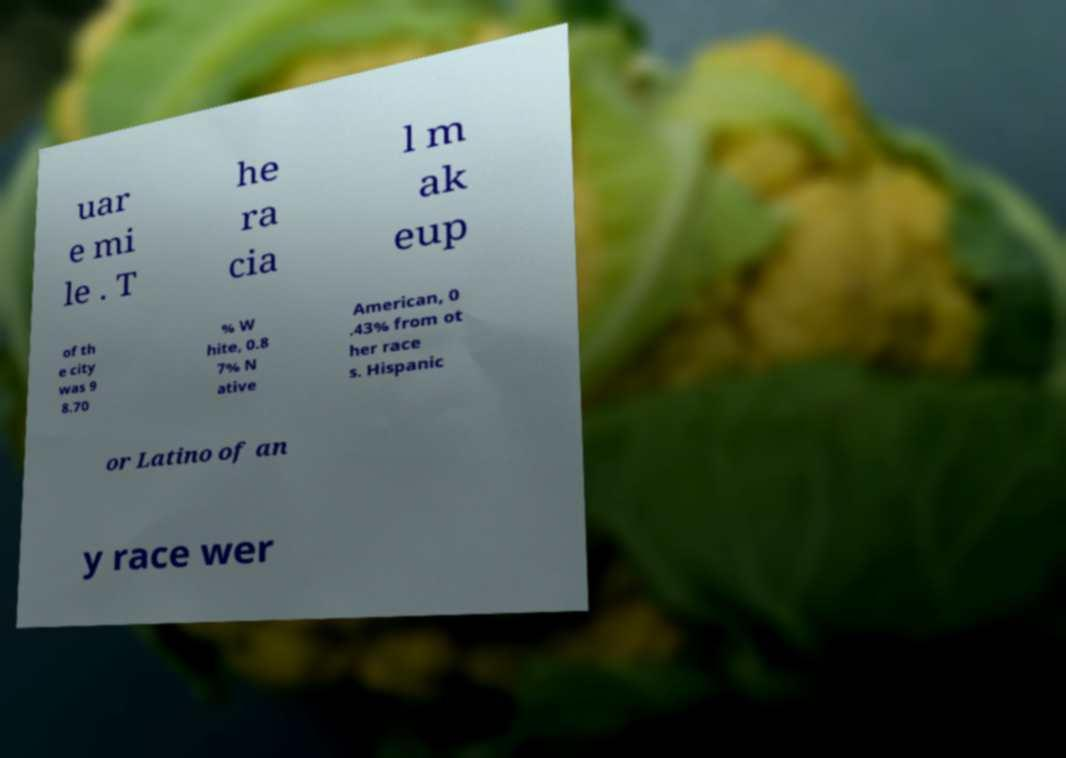Can you accurately transcribe the text from the provided image for me? uar e mi le . T he ra cia l m ak eup of th e city was 9 8.70 % W hite, 0.8 7% N ative American, 0 .43% from ot her race s. Hispanic or Latino of an y race wer 